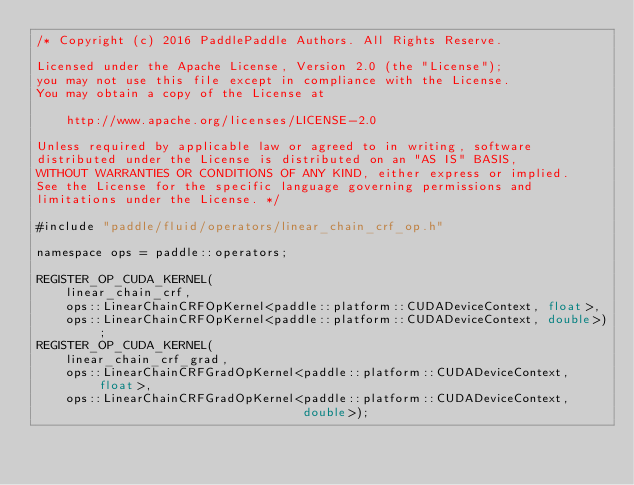Convert code to text. <code><loc_0><loc_0><loc_500><loc_500><_Cuda_>/* Copyright (c) 2016 PaddlePaddle Authors. All Rights Reserve.

Licensed under the Apache License, Version 2.0 (the "License");
you may not use this file except in compliance with the License.
You may obtain a copy of the License at

    http://www.apache.org/licenses/LICENSE-2.0

Unless required by applicable law or agreed to in writing, software
distributed under the License is distributed on an "AS IS" BASIS,
WITHOUT WARRANTIES OR CONDITIONS OF ANY KIND, either express or implied.
See the License for the specific language governing permissions and
limitations under the License. */

#include "paddle/fluid/operators/linear_chain_crf_op.h"

namespace ops = paddle::operators;

REGISTER_OP_CUDA_KERNEL(
    linear_chain_crf,
    ops::LinearChainCRFOpKernel<paddle::platform::CUDADeviceContext, float>,
    ops::LinearChainCRFOpKernel<paddle::platform::CUDADeviceContext, double>);
REGISTER_OP_CUDA_KERNEL(
    linear_chain_crf_grad,
    ops::LinearChainCRFGradOpKernel<paddle::platform::CUDADeviceContext, float>,
    ops::LinearChainCRFGradOpKernel<paddle::platform::CUDADeviceContext,
                                    double>);
</code> 